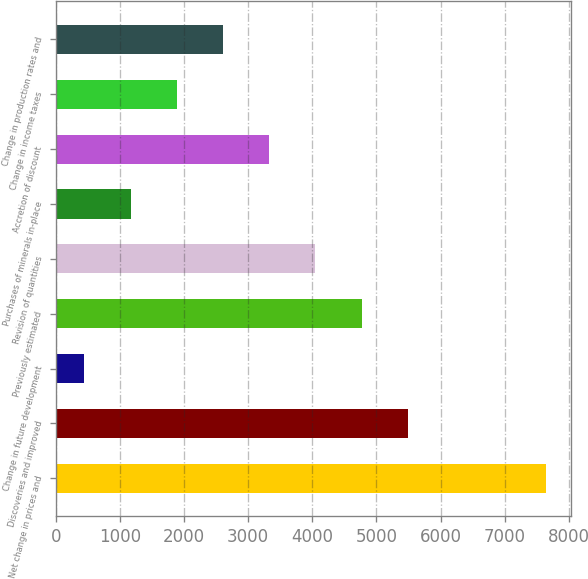<chart> <loc_0><loc_0><loc_500><loc_500><bar_chart><fcel>Net change in prices and<fcel>Discoveries and improved<fcel>Change in future development<fcel>Previously estimated<fcel>Revision of quantities<fcel>Purchases of minerals in-place<fcel>Accretion of discount<fcel>Change in income taxes<fcel>Change in production rates and<nl><fcel>7650<fcel>5489.1<fcel>447<fcel>4768.8<fcel>4048.5<fcel>1167.3<fcel>3328.2<fcel>1887.6<fcel>2607.9<nl></chart> 